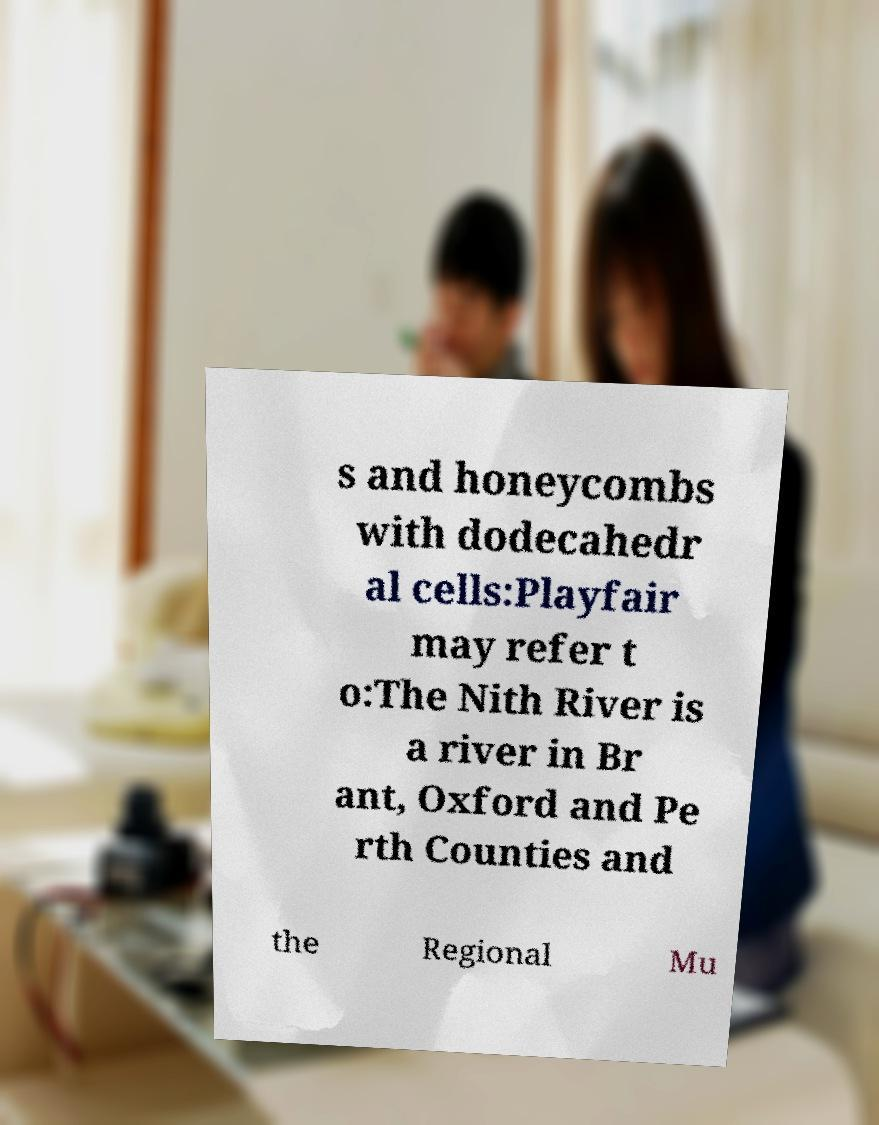Could you extract and type out the text from this image? s and honeycombs with dodecahedr al cells:Playfair may refer t o:The Nith River is a river in Br ant, Oxford and Pe rth Counties and the Regional Mu 